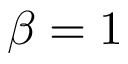<formula> <loc_0><loc_0><loc_500><loc_500>\beta = 1</formula> 